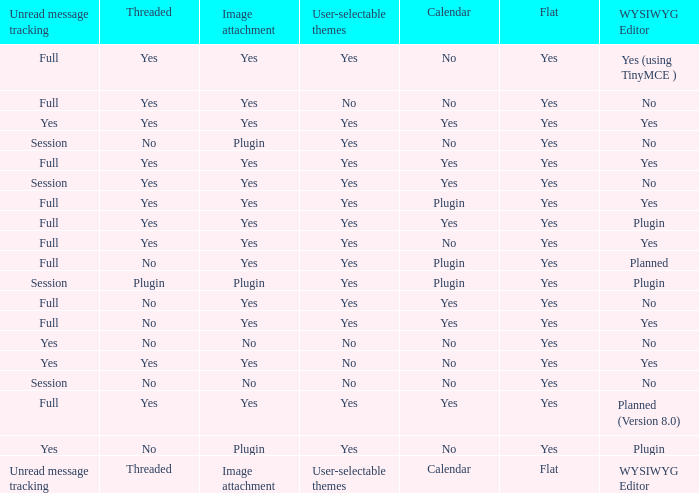Which WYSIWYG Editor has an Image attachment of yes, and a Calendar of plugin? Yes, Planned. 